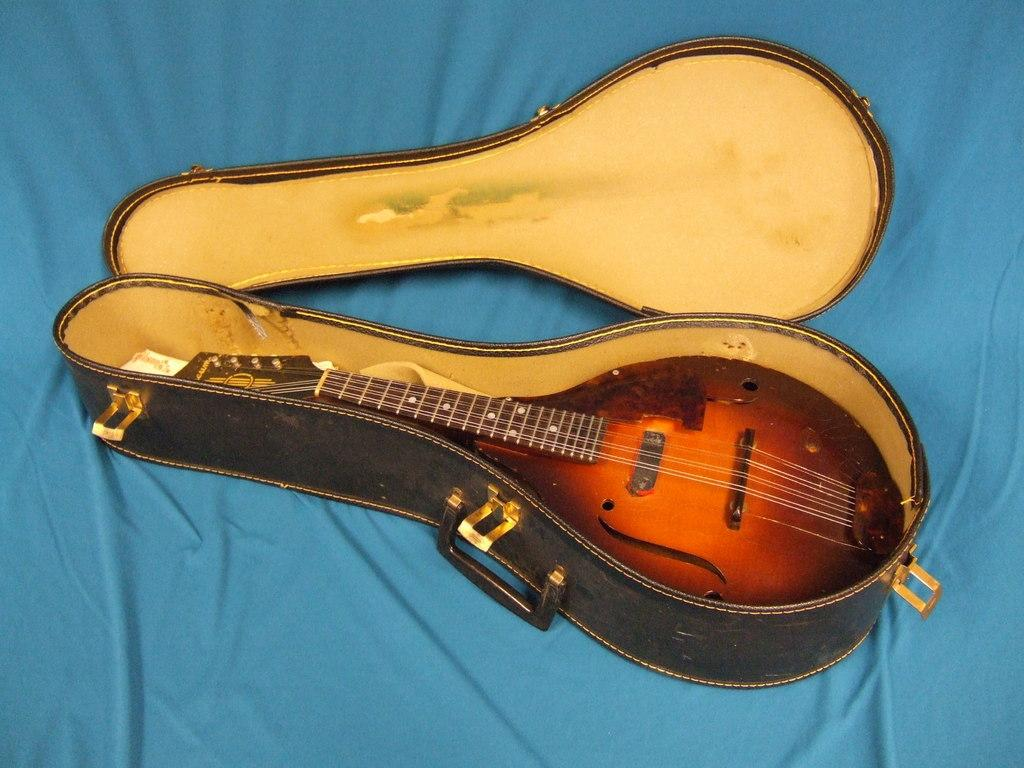What musical instrument is present in the image? There is a mandolin in the image. How is the mandolin being stored or transported? The mandolin is in its box. What part of the box is visible in the image? The lid of the box is beside the mandolin. What type of wound can be seen on the mandolin in the image? There is no wound visible on the mandolin in the image. 